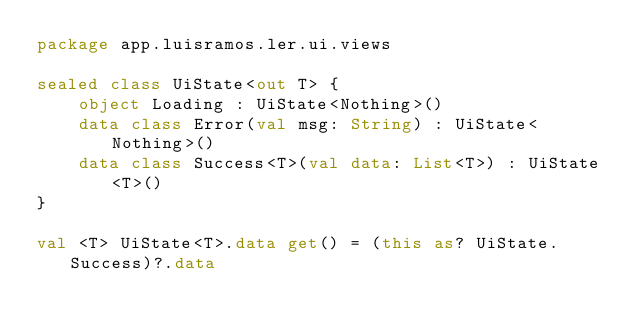<code> <loc_0><loc_0><loc_500><loc_500><_Kotlin_>package app.luisramos.ler.ui.views

sealed class UiState<out T> {
    object Loading : UiState<Nothing>()
    data class Error(val msg: String) : UiState<Nothing>()
    data class Success<T>(val data: List<T>) : UiState<T>()
}

val <T> UiState<T>.data get() = (this as? UiState.Success)?.data</code> 